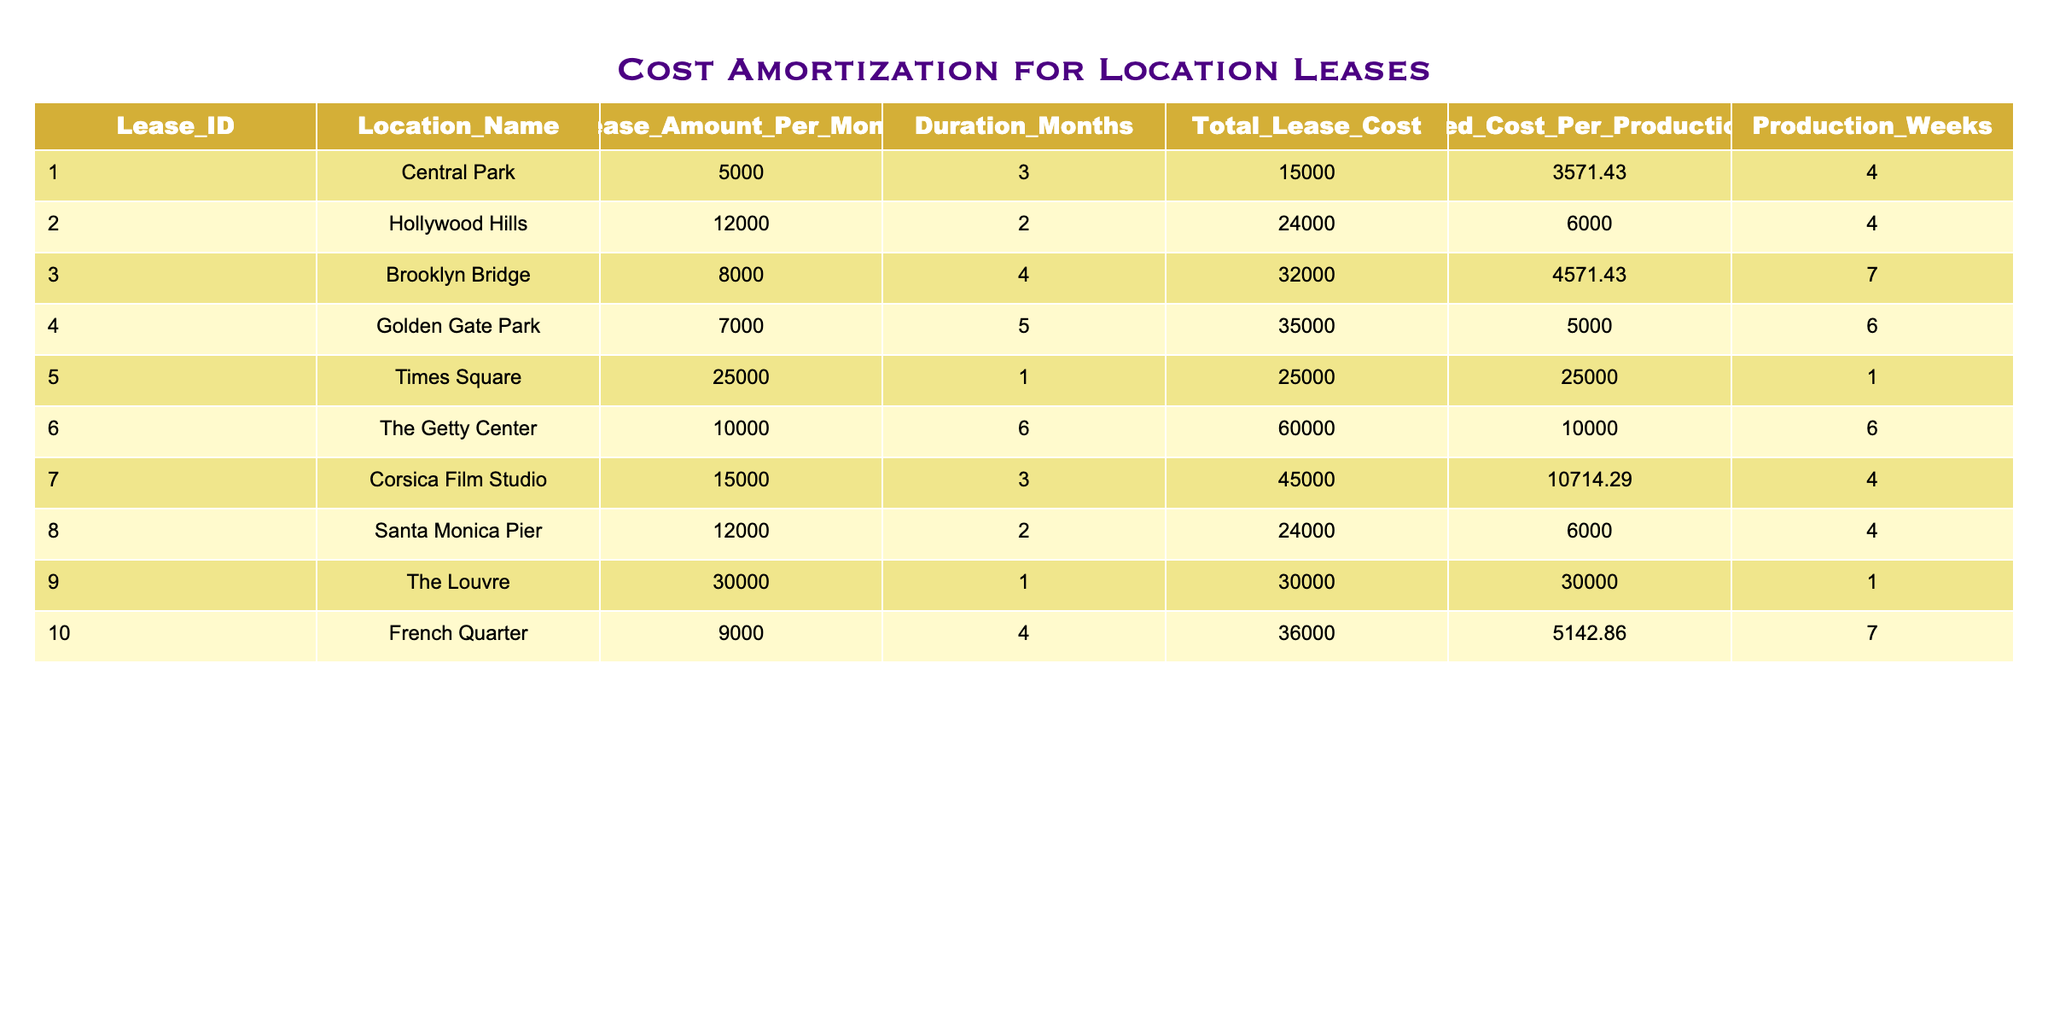What is the total lease cost for the Brooklyn Bridge? The total lease cost for the Brooklyn Bridge is found in the "Total Lease Cost" column for the corresponding row (Lease_ID 3), which lists $32,000.
Answer: 32000 What is the amortized cost per production week for Central Park? To find the answer, refer to the "Amortized Cost Per Production Week" column for Central Park (Lease_ID 1), which states $3,571.43.
Answer: 3571.43 Which location has the highest lease amount per month? The "Lease Amount Per Month" column shows the values for each location. The highest value in this column is $25,000 for Times Square.
Answer: 25000 Is the total lease cost for Golden Gate Park greater than $30,000? Checking the "Total Lease Cost" column for Golden Gate Park (Lease_ID 4), the value is $35,000, which is indeed greater than $30,000.
Answer: Yes What is the average amortized cost per production week of all leases? To calculate the average, sum all the values in the "Amortized Cost Per Production Week" column: (3571.43 + 6000 + 4571.43 + 5000 + 25000 + 10000 + 10714.29 + 6000 + 30000 + 5142.86) = 100,000; divide by 10 (the number of rows) to get the average: 100,000/10 = 10,000.
Answer: 10000 Which two locations have the same amortized cost per production week? By examining the "Amortized Cost Per Production Week" column values, Corsica Film Studio (Lease_ID 7) and Golden Gate Park (Lease_ID 4) both share a value of 5,000.
Answer: Corsica Film Studio and Golden Gate Park How many production weeks were required for filming at Times Square? The "Production Weeks" column identifies that there was only 1 production week required for Times Square (Lease_ID 5).
Answer: 1 Which lease has the lowest amortized cost per production week? The lowest value in the "Amortized Cost Per Production Week" column is seen for Times Square at $25,000, which is higher than any value for other leases.
Answer: Times Square Did the Hollywood Hills lease last longer than 3 months? The "Duration Months" column shows that the Hollywood Hills lease (Lease_ID 2) lasted for 2 months, which is less than 3 months.
Answer: No 